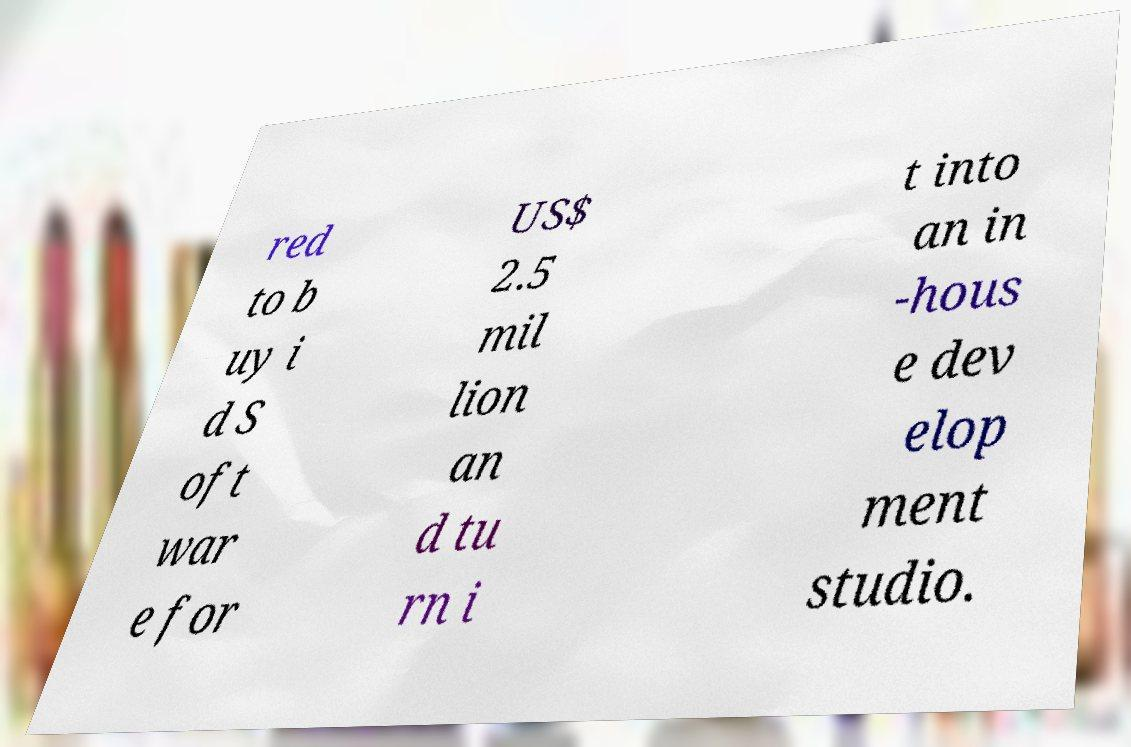Could you extract and type out the text from this image? red to b uy i d S oft war e for US$ 2.5 mil lion an d tu rn i t into an in -hous e dev elop ment studio. 